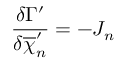Convert formula to latex. <formula><loc_0><loc_0><loc_500><loc_500>\frac { \delta \Gamma ^ { \prime } } { \delta \overline { \chi } _ { n } ^ { \prime } } = - J _ { n }</formula> 